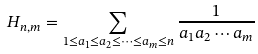Convert formula to latex. <formula><loc_0><loc_0><loc_500><loc_500>H _ { n , m } = \sum _ { 1 \leq a _ { 1 } \leq a _ { 2 } \leq \cdots \leq a _ { m } \leq n } \frac { 1 } { a _ { 1 } a _ { 2 } \cdots a _ { m } }</formula> 